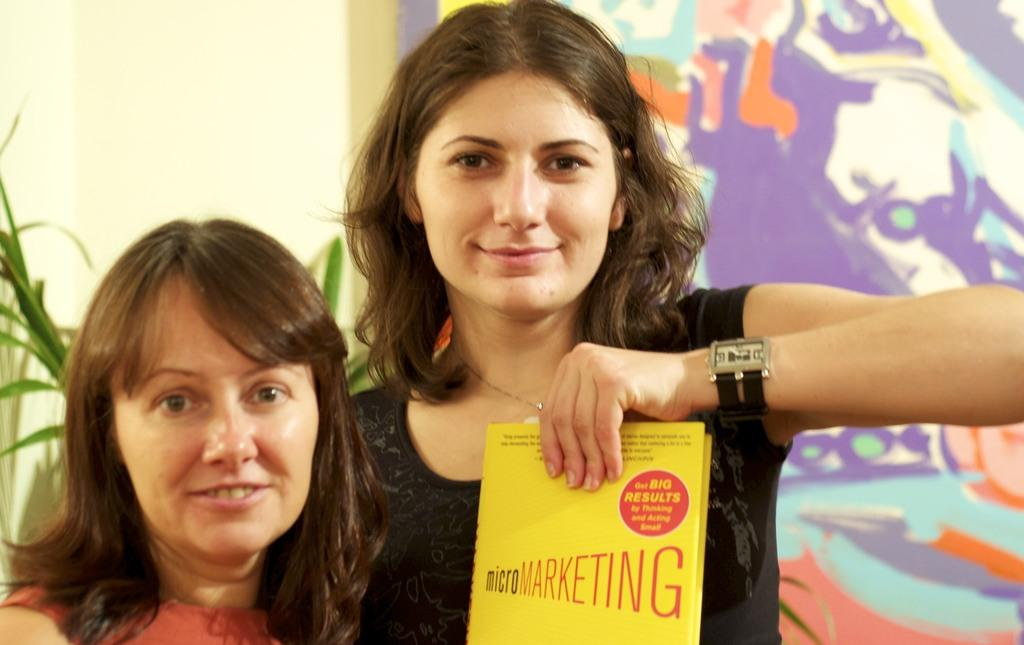Provide a one-sentence caption for the provided image. Woman holding a yellow book which says microMarketing. 